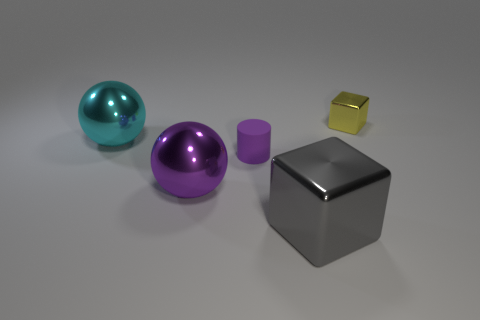Subtract 2 cubes. How many cubes are left? 0 Subtract 0 yellow cylinders. How many objects are left? 5 Subtract all balls. How many objects are left? 3 Subtract all brown blocks. Subtract all gray cylinders. How many blocks are left? 2 Subtract all gray cylinders. How many cyan balls are left? 1 Subtract all purple matte balls. Subtract all cubes. How many objects are left? 3 Add 3 rubber things. How many rubber things are left? 4 Add 1 matte things. How many matte things exist? 2 Add 3 tiny cyan metallic cubes. How many objects exist? 8 